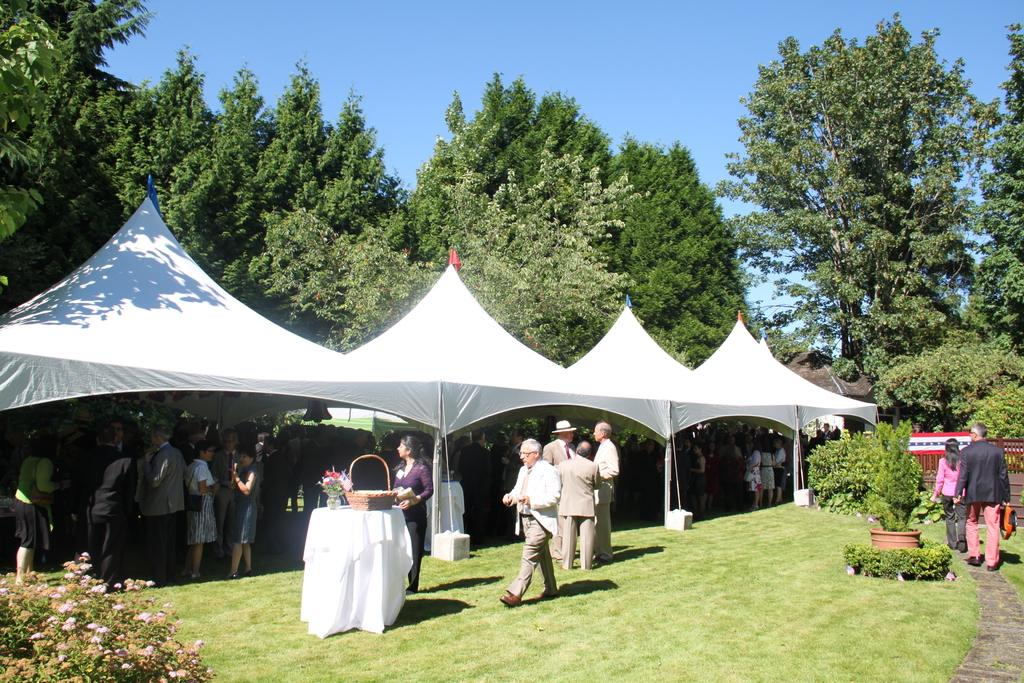What can be seen in the image in terms of human presence? There are people standing in the image. What type of structures are present in the image? There are white color tents in the image. What type of vegetation is visible in the image? There are green trees in the image. What is the color of the sky in the image? The sky is blue in the image. Are there any cherries hanging from the trees in the image? There is no mention of cherries in the provided facts, and therefore we cannot determine if they are present in the image. What type of plastic objects can be seen in the image? There is no mention of plastic objects in the provided facts, and therefore we cannot determine if they are present in the image. 